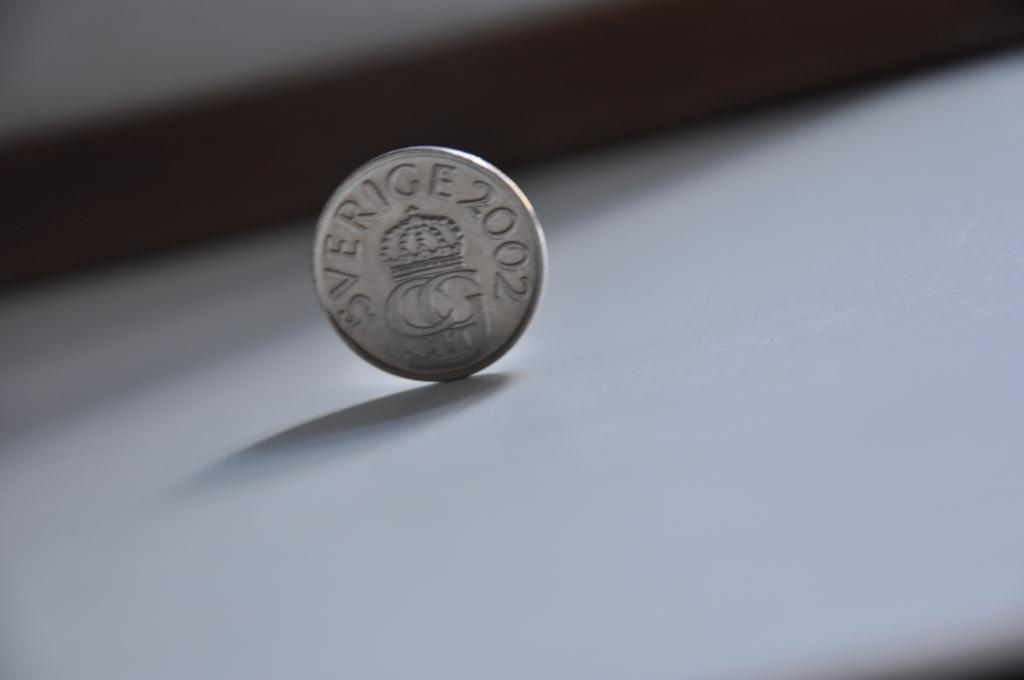<image>
Relay a brief, clear account of the picture shown. A coin, balanced on its edge that says Sverige 2002. 